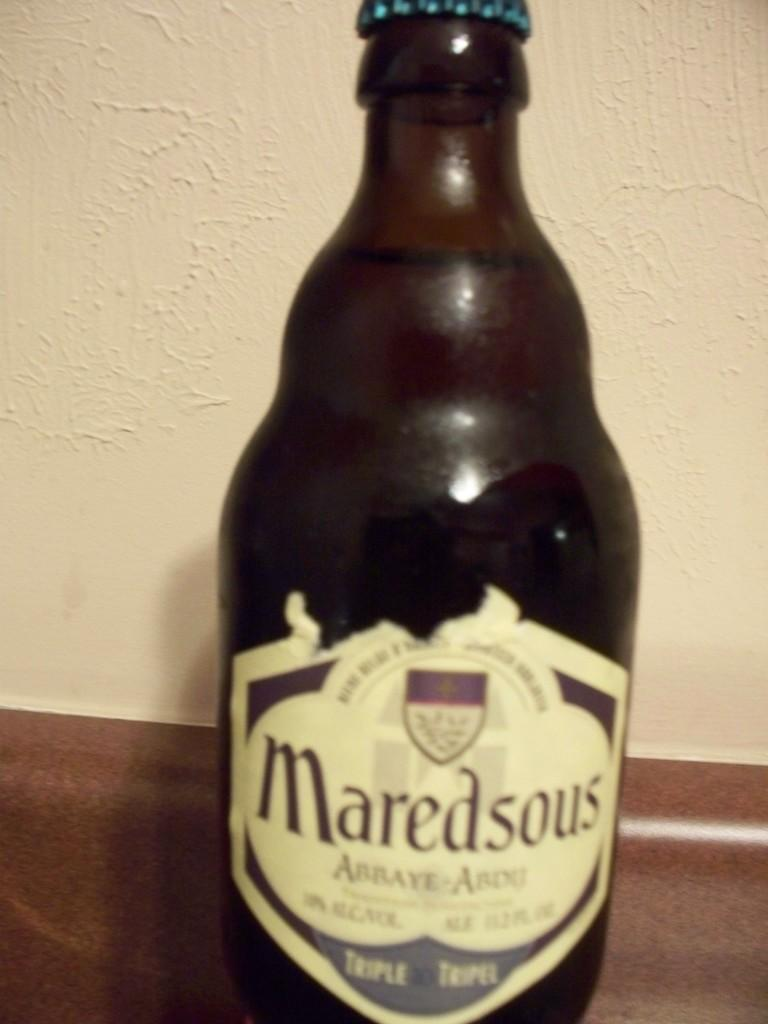<image>
Render a clear and concise summary of the photo. Maredsous sits on a brown counter with a white walle 